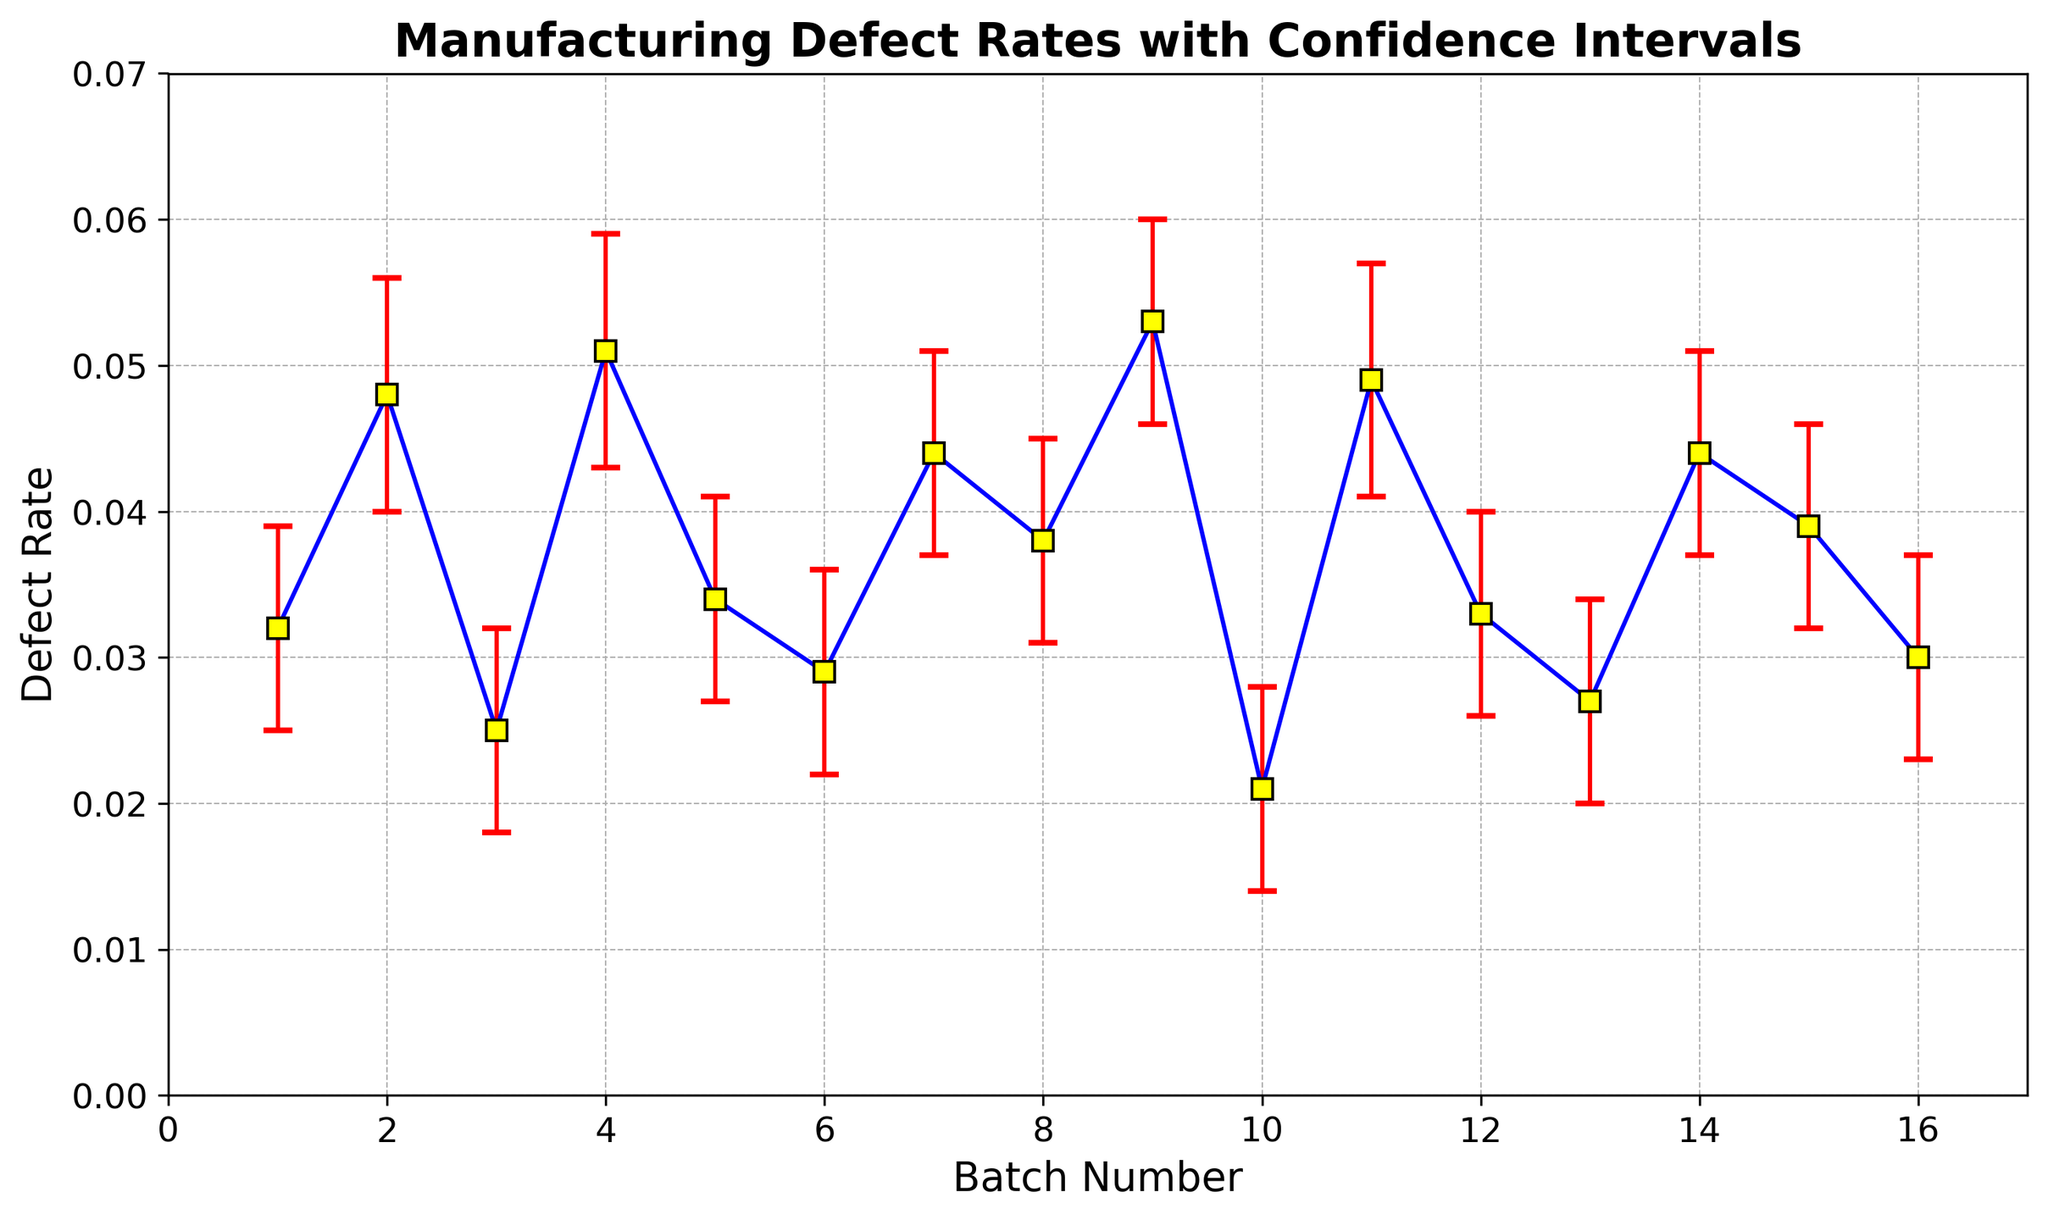What is the range of defect rates observed in the batches? The defect rates range from the minimum defect rate value to the maximum defect rate value observed in the figure. The minimum defect rate is from batch 10 at 0.021, and the maximum defect rate is from batch 9 at 0.053.
Answer: 0.021 to 0.053 Which batch has the highest defect rate? By looking at the highest points in the figure corresponding to defect rates, the highest defect rate is observed in batch 9 with a defect rate of 0.053.
Answer: Batch 9 What is the average defect rate across all batches? Sum all the defect rates and divide by the number of batches (16). Sum = 0.032 + 0.048 + 0.025 + 0.051 + 0.034 + 0.029 + 0.044 + 0.038 + 0.053 + 0.021 + 0.049 + 0.033 + 0.027 + 0.044 + 0.039 + 0.030 = 0.597. Average = 0.597 / 16
Answer: 0.0373 Which batches have overlapping confidence intervals, and what does that imply? Overlapping confidence intervals can be identified visually where the error bars intersect each other. For example, batches 4 and 5 have overlapping intervals, implying their defect rates are not significantly different from one another.
Answer: Batches 4 and 5 Does batch 14 have a higher defect rate than batch 7? By comparing the defect rates for batch 14 and batch 7, both have a defect rate of 0.044, so they have equal defect rates.
Answer: No What is the defect rate for batch 12 and the uncertainty associated with it? The defect rate for batch 12 is observed as 0.033. The uncertainty ranges from the lower bound of 0.026 to the upper bound of 0.040. This means that the defect rate could vary between 0.026 and 0.040.
Answer: 0.033, [0.026, 0.040] Which two batches have the smallest and the largest confidence intervals, and what are their ranges? By visually inspecting the lengths of the error bars, batch 15 has the smallest confidence interval (0.039 ± 0.007) and batch 9 has the largest confidence interval (0.053 ± 0.007).
Answer: Batch 15: [0.032, 0.046], Batch 9: [0.046, 0.060] Are there any batches with defect rates lower than 0.03? By inspecting the defect rates, batches 3, 6, 10, and 13 have defect rates lower than 0.03.
Answer: Yes What can be inferred about the consistency of defect rates for batches with the smallest confidence intervals? Batches with smaller confidence intervals, like batch 15, indicate more consistent manufacturing processes with less variability in the defect rates.
Answer: More consistency 